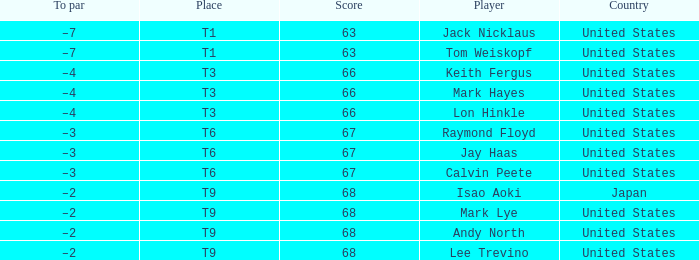What is the total number of Score, when Country is "United States", and when Player is "Lee Trevino"? 1.0. 